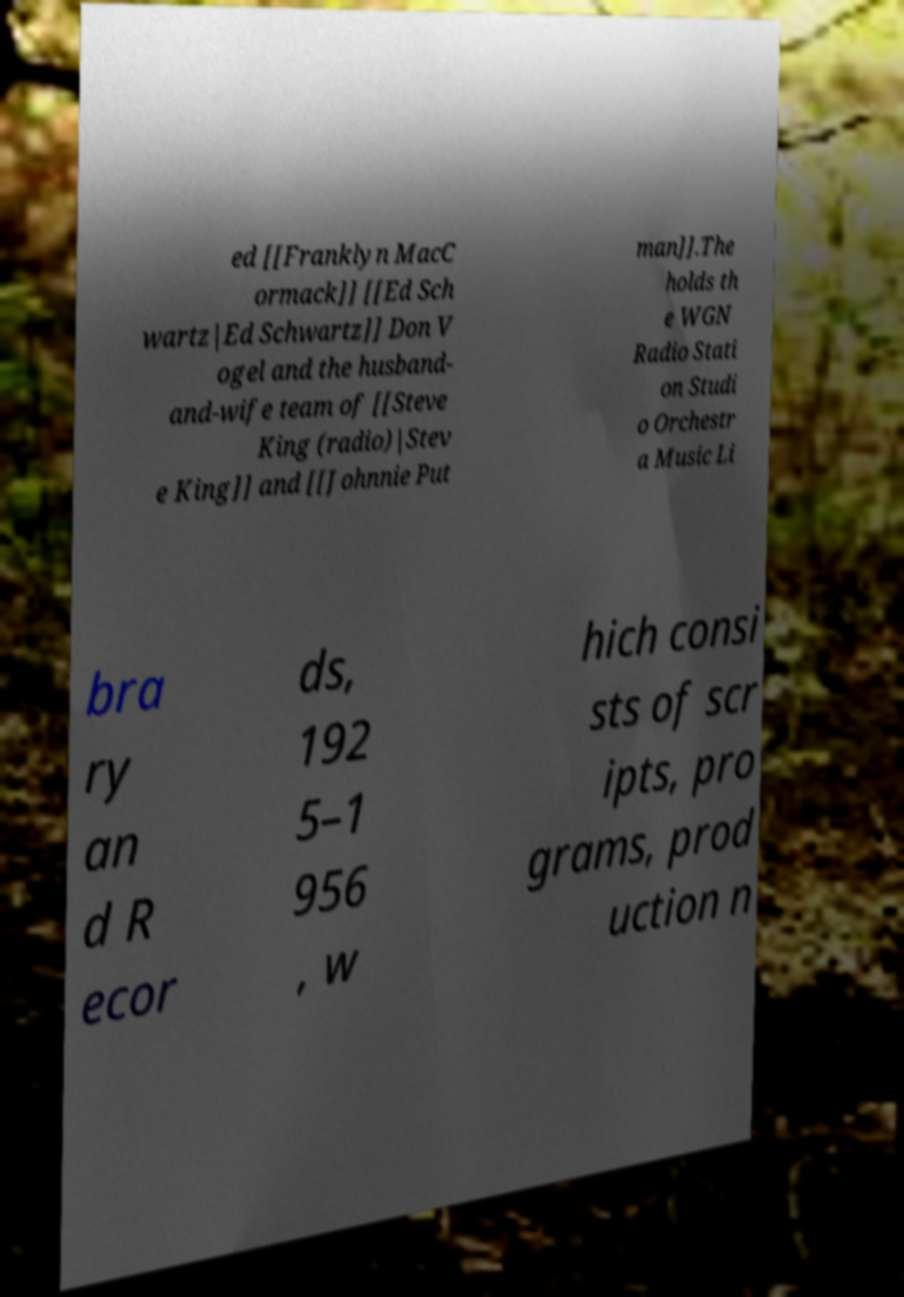For documentation purposes, I need the text within this image transcribed. Could you provide that? ed [[Franklyn MacC ormack]] [[Ed Sch wartz|Ed Schwartz]] Don V ogel and the husband- and-wife team of [[Steve King (radio)|Stev e King]] and [[Johnnie Put man]].The holds th e WGN Radio Stati on Studi o Orchestr a Music Li bra ry an d R ecor ds, 192 5–1 956 , w hich consi sts of scr ipts, pro grams, prod uction n 